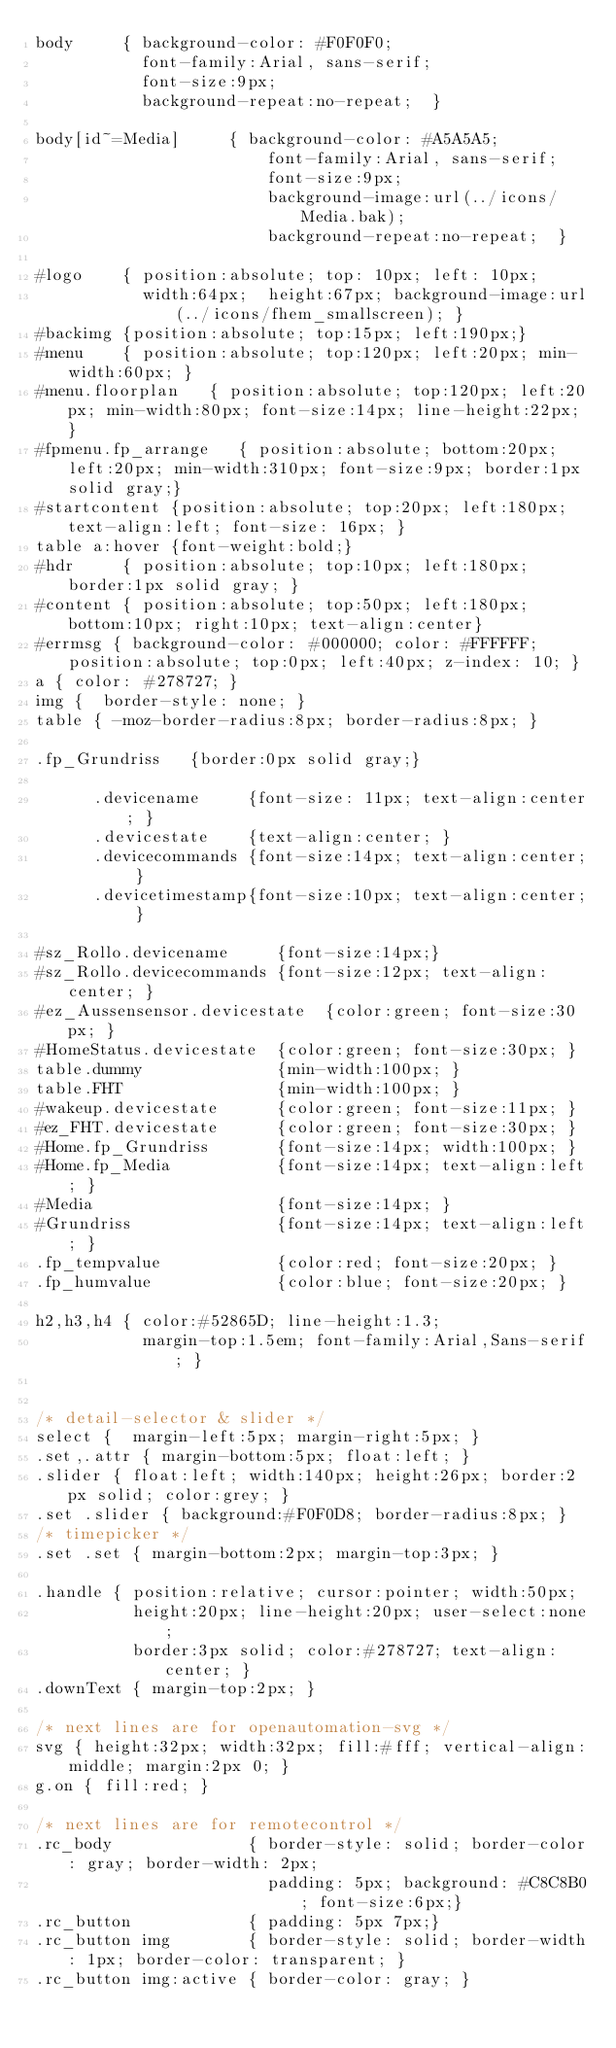Convert code to text. <code><loc_0><loc_0><loc_500><loc_500><_CSS_>body     { background-color: #F0F0F0;
           font-family:Arial, sans-serif; 
           font-size:9px; 
           background-repeat:no-repeat;  }

body[id~=Media]     { background-color: #A5A5A5;
                        font-family:Arial, sans-serif; 
                        font-size:9px;  
                        background-image:url(../icons/Media.bak);
                        background-repeat:no-repeat;  }

#logo    { position:absolute; top: 10px; left: 10px; 
           width:64px;  height:67px; background-image:url(../icons/fhem_smallscreen); }
#backimg {position:absolute; top:15px; left:190px;}
#menu    { position:absolute; top:120px; left:20px; min-width:60px; }
#menu.floorplan   { position:absolute; top:120px; left:20px; min-width:80px; font-size:14px; line-height:22px; }
#fpmenu.fp_arrange   { position:absolute; bottom:20px; left:20px; min-width:310px; font-size:9px; border:1px solid gray;}
#startcontent {position:absolute; top:20px; left:180px; text-align:left; font-size: 16px; } 
table a:hover {font-weight:bold;}
#hdr     { position:absolute; top:10px; left:180px; border:1px solid gray; }
#content { position:absolute; top:50px; left:180px; bottom:10px; right:10px; text-align:center}
#errmsg { background-color: #000000; color: #FFFFFF; position:absolute; top:0px; left:40px; z-index: 10; }
a { color: #278727; }
img {  border-style: none; }
table { -moz-border-radius:8px; border-radius:8px; }

.fp_Grundriss   {border:0px solid gray;}

      .devicename     {font-size: 11px; text-align:center; }
      .devicestate    {text-align:center; }
      .devicecommands {font-size:14px; text-align:center; }
      .devicetimestamp{font-size:10px; text-align:center; }

#sz_Rollo.devicename     {font-size:14px;}
#sz_Rollo.devicecommands {font-size:12px; text-align:center; }
#ez_Aussensensor.devicestate  {color:green; font-size:30px; }
#HomeStatus.devicestate  {color:green; font-size:30px; }
table.dummy              {min-width:100px; }
table.FHT                {min-width:100px; }
#wakeup.devicestate      {color:green; font-size:11px; }
#ez_FHT.devicestate      {color:green; font-size:30px; }
#Home.fp_Grundriss       {font-size:14px; width:100px; }
#Home.fp_Media           {font-size:14px; text-align:left; }
#Media                   {font-size:14px; }
#Grundriss               {font-size:14px; text-align:left; }
.fp_tempvalue            {color:red; font-size:20px; }
.fp_humvalue             {color:blue; font-size:20px; } 

h2,h3,h4 { color:#52865D; line-height:1.3;
           margin-top:1.5em; font-family:Arial,Sans-serif; }


/* detail-selector & slider */
select {  margin-left:5px; margin-right:5px; }
.set,.attr { margin-bottom:5px; float:left; }
.slider { float:left; width:140px; height:26px; border:2px solid; color:grey; }
.set .slider { background:#F0F0D8; border-radius:8px; }
/* timepicker */
.set .set { margin-bottom:2px; margin-top:3px; }

.handle { position:relative; cursor:pointer; width:50px;
          height:20px; line-height:20px; user-select:none;
          border:3px solid; color:#278727; text-align:center; } 
.downText { margin-top:2px; }

/* next lines are for openautomation-svg */
svg { height:32px; width:32px; fill:#fff; vertical-align:middle; margin:2px 0; }
g.on { fill:red; }

/* next lines are for remotecontrol */
.rc_body              { border-style: solid; border-color: gray; border-width: 2px; 
                        padding: 5px; background: #C8C8B0; font-size:6px;}
.rc_button            { padding: 5px 7px;}
.rc_button img        { border-style: solid; border-width: 1px; border-color: transparent; }
.rc_button img:active { border-color: gray; }
</code> 